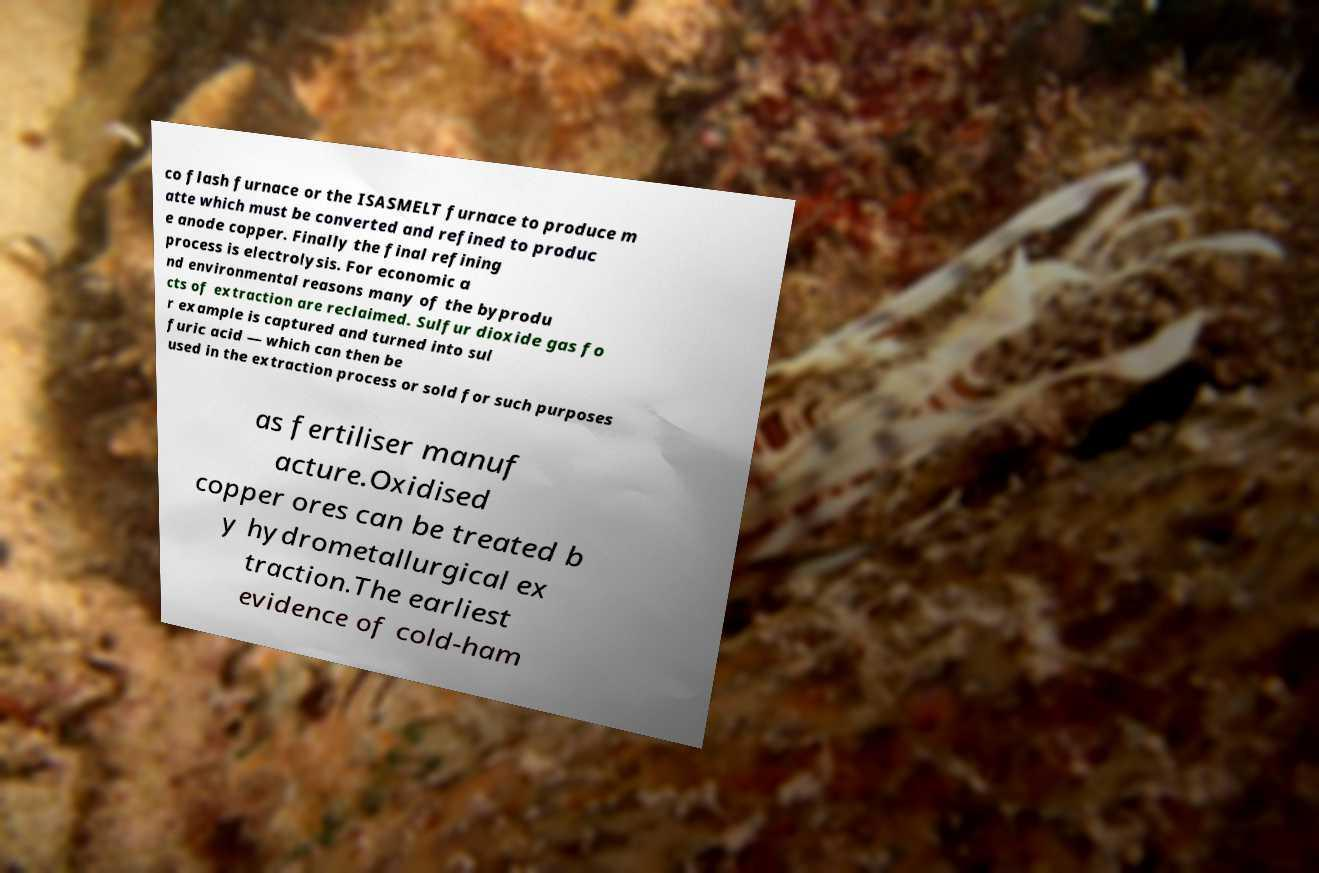Can you accurately transcribe the text from the provided image for me? co flash furnace or the ISASMELT furnace to produce m atte which must be converted and refined to produc e anode copper. Finally the final refining process is electrolysis. For economic a nd environmental reasons many of the byprodu cts of extraction are reclaimed. Sulfur dioxide gas fo r example is captured and turned into sul furic acid — which can then be used in the extraction process or sold for such purposes as fertiliser manuf acture.Oxidised copper ores can be treated b y hydrometallurgical ex traction.The earliest evidence of cold-ham 